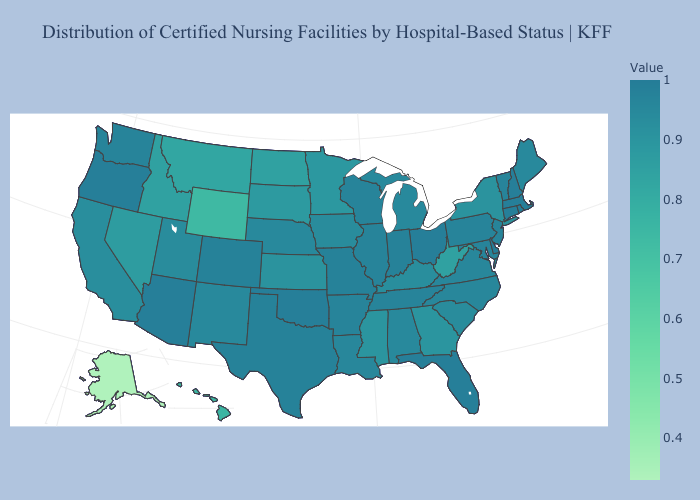Does Rhode Island have the highest value in the Northeast?
Be succinct. Yes. Which states hav the highest value in the South?
Quick response, please. Delaware. Which states have the lowest value in the Northeast?
Short answer required. New York. Which states have the lowest value in the USA?
Concise answer only. Alaska. Which states have the lowest value in the USA?
Be succinct. Alaska. 